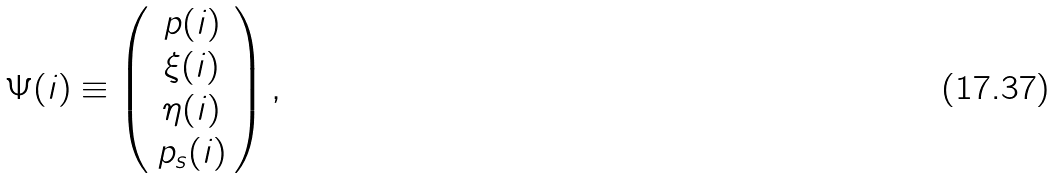Convert formula to latex. <formula><loc_0><loc_0><loc_500><loc_500>\Psi ( i ) \equiv \left ( \begin{array} { c } p ( i ) \\ \xi ( i ) \\ \eta ( i ) \\ p _ { s } ( i ) \end{array} \right ) ,</formula> 